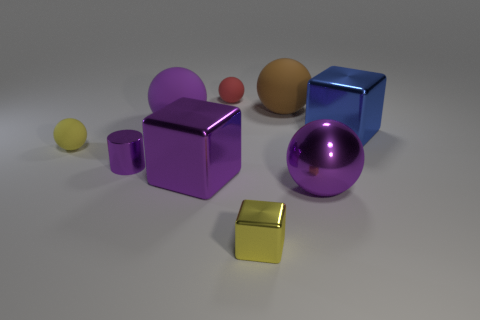What is the shape of the matte thing in front of the large purple sphere behind the tiny yellow rubber object?
Provide a succinct answer. Sphere. Are there fewer tiny spheres that are on the right side of the large purple block than large brown matte objects in front of the yellow cube?
Give a very brief answer. No. The metal object that is the same shape as the purple rubber thing is what color?
Make the answer very short. Purple. What number of tiny objects are in front of the yellow matte sphere and behind the tiny yellow sphere?
Ensure brevity in your answer.  0. Are there more yellow spheres behind the big purple rubber ball than yellow rubber objects that are in front of the small purple cylinder?
Provide a succinct answer. No. What size is the brown matte sphere?
Your response must be concise. Large. Are there any purple metal things of the same shape as the large purple matte object?
Give a very brief answer. Yes. Does the blue thing have the same shape as the tiny yellow thing in front of the small purple thing?
Ensure brevity in your answer.  Yes. There is a thing that is right of the brown matte sphere and in front of the small yellow sphere; how big is it?
Offer a very short reply. Large. How many purple rubber balls are there?
Provide a succinct answer. 1. 